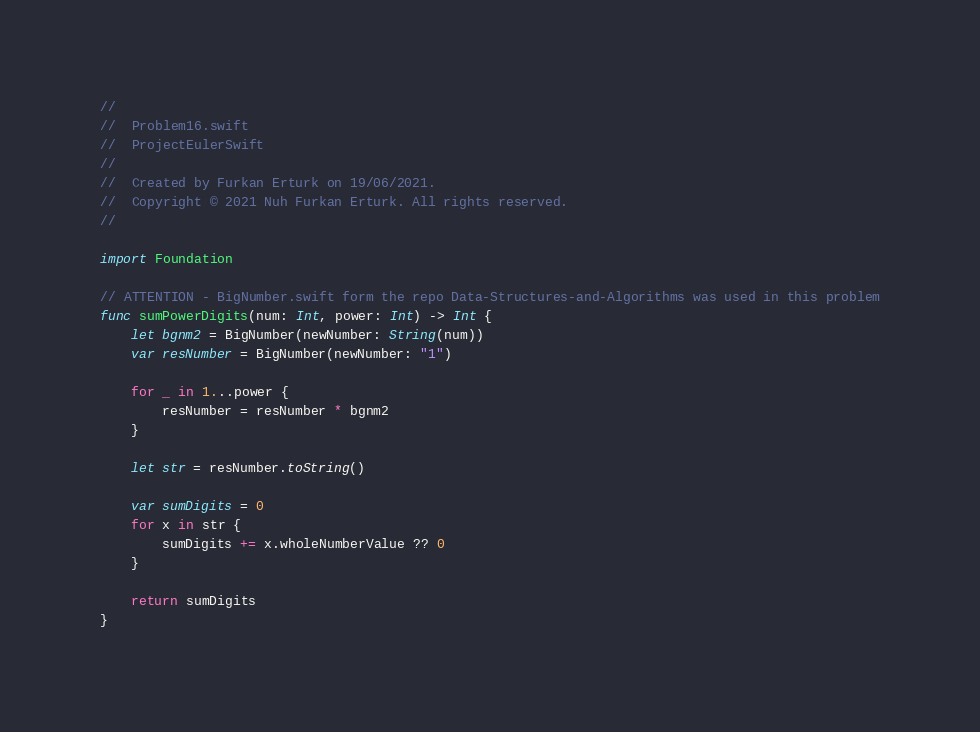Convert code to text. <code><loc_0><loc_0><loc_500><loc_500><_Swift_>//
//  Problem16.swift
//  ProjectEulerSwift
//
//  Created by Furkan Erturk on 19/06/2021.
//  Copyright © 2021 Nuh Furkan Erturk. All rights reserved.
//

import Foundation

// ATTENTION - BigNumber.swift form the repo Data-Structures-and-Algorithms was used in this problem
func sumPowerDigits(num: Int, power: Int) -> Int {
    let bgnm2 = BigNumber(newNumber: String(num))
    var resNumber = BigNumber(newNumber: "1")
    
    for _ in 1...power {
        resNumber = resNumber * bgnm2
    }
    
    let str = resNumber.toString()
    
    var sumDigits = 0
    for x in str {
        sumDigits += x.wholeNumberValue ?? 0
    }
    
    return sumDigits
}

</code> 